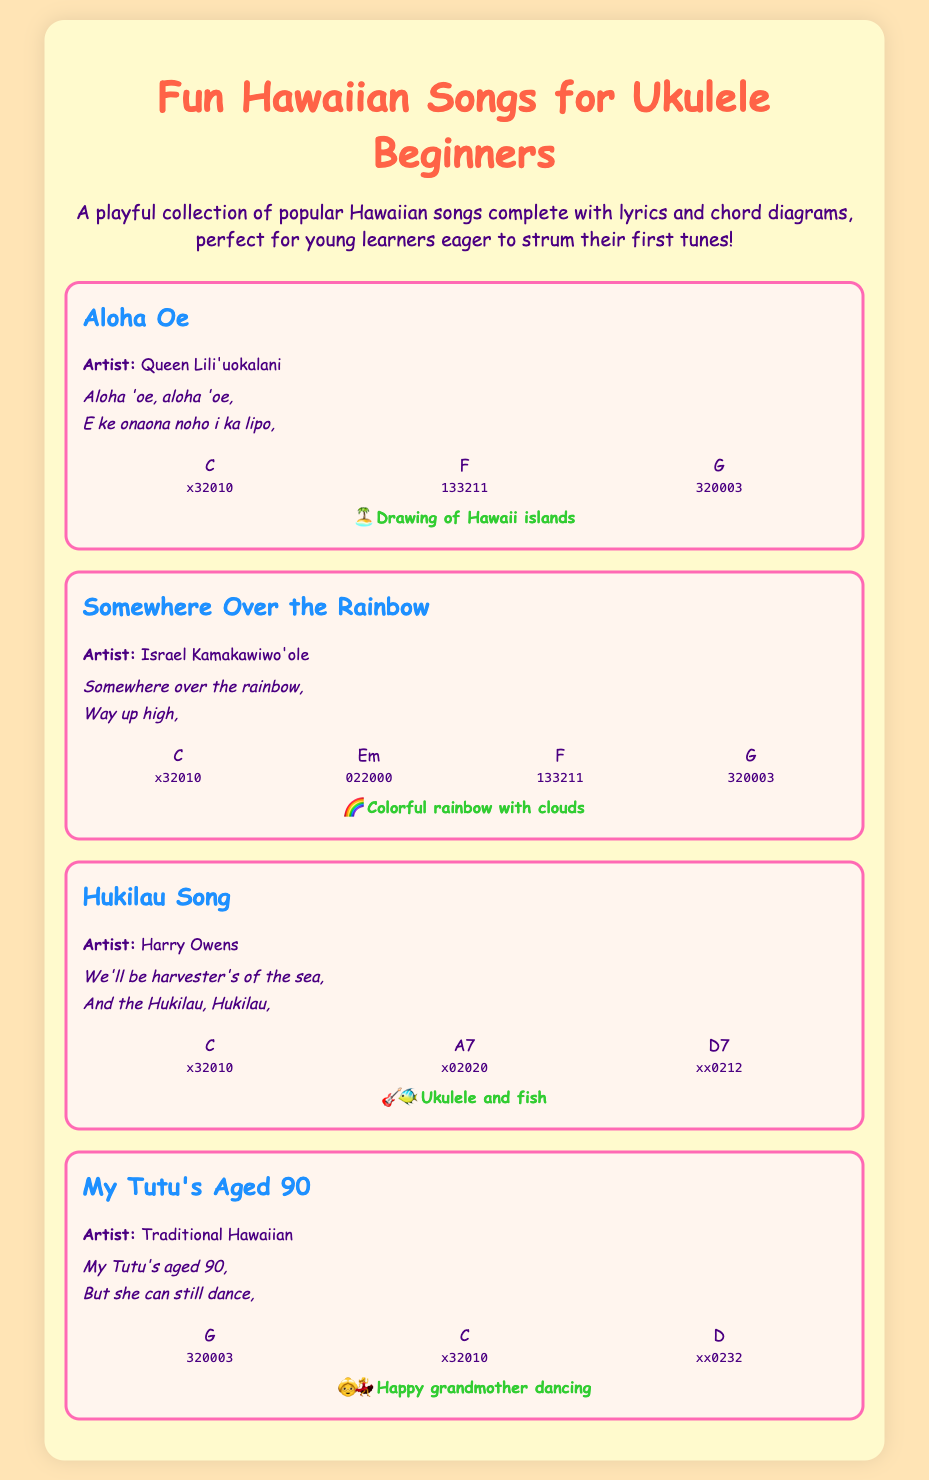What is the title of the catalog? The title of the catalog is stated at the top of the document.
Answer: Fun Hawaiian Songs for Ukulele Beginners Who is the artist of "Somewhere Over the Rainbow"? The artist is listed directly under the song title.
Answer: Israel Kamakawiwo'ole How many chords are used for "Hukilau Song"? The number of chord diagrams is counted within the song section.
Answer: 3 What is the first line of the lyrics for "Aloha Oe"? The first line of the lyrics is provided in the lyrics section.
Answer: Aloha 'oe, aloha 'oe, Which song features a rainbow illustration? The song with a specific illustration is found in the song descriptions.
Answer: Somewhere Over the Rainbow Which chord diagram is used in "My Tutu's Aged 90"? Chords are clearly listed under each song title, identifying specific chords.
Answer: G What is the color of the text used for song titles? The color of the text is defined in the style section and applied to song titles.
Answer: Blue What type of music is this catalog focused on? The overall theme of the document is described in the introductory description.
Answer: Hawaiian music 